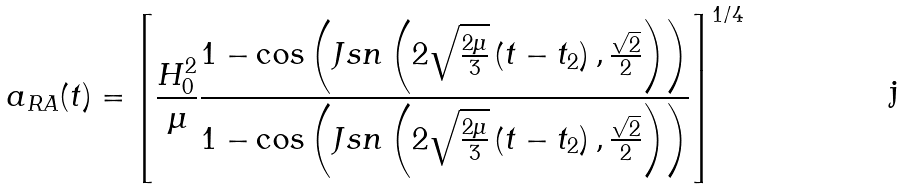Convert formula to latex. <formula><loc_0><loc_0><loc_500><loc_500>a _ { R A } ( t ) = { \left [ \frac { H _ { 0 } ^ { 2 } } { \mu } \frac { 1 - \cos \left ( J s n \left ( 2 \sqrt { \frac { 2 \mu } { 3 } } \left ( t - t _ { 2 } \right ) , \frac { \sqrt { 2 } } { 2 } \right ) \right ) } { 1 - \cos \left ( J s n \left ( 2 \sqrt { \frac { 2 \mu } { 3 } } \left ( t - t _ { 2 } \right ) , \frac { \sqrt { 2 } } { 2 } \right ) \right ) } \right ] } ^ { 1 / 4 }</formula> 